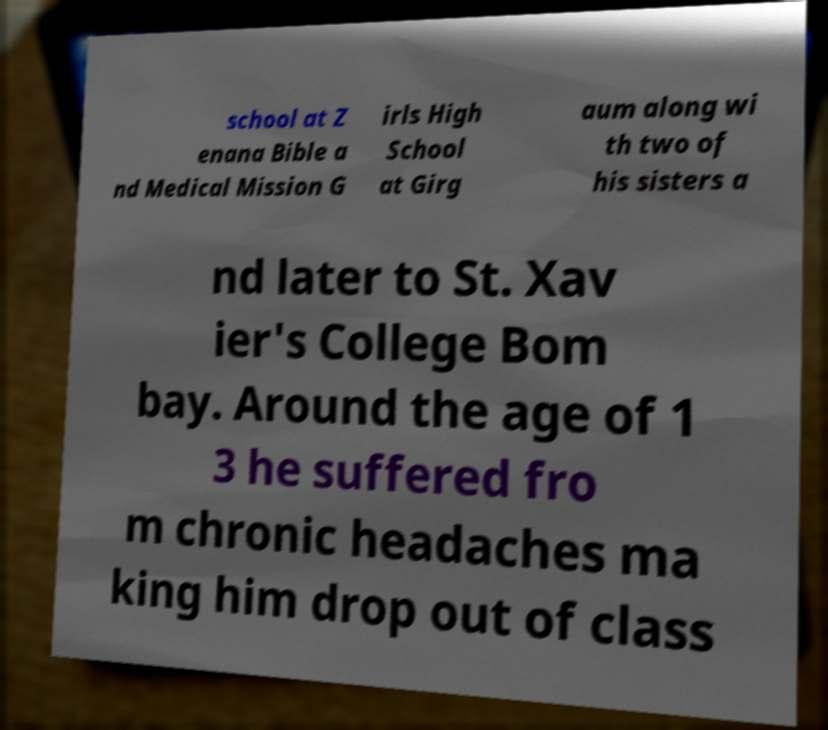Please read and relay the text visible in this image. What does it say? school at Z enana Bible a nd Medical Mission G irls High School at Girg aum along wi th two of his sisters a nd later to St. Xav ier's College Bom bay. Around the age of 1 3 he suffered fro m chronic headaches ma king him drop out of class 